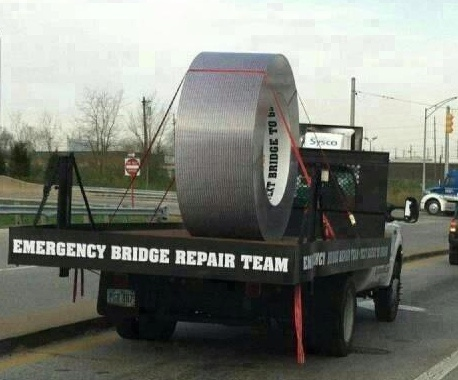Describe the objects in this image and their specific colors. I can see truck in ivory, black, gray, darkgray, and lightgray tones, car in ivory, gray, black, blue, and darkgray tones, car in ivory, black, gray, and maroon tones, and traffic light in ivory, tan, and beige tones in this image. 